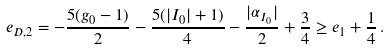<formula> <loc_0><loc_0><loc_500><loc_500>e _ { D , 2 } & = - \frac { 5 ( g _ { 0 } - 1 ) } { 2 } - \frac { 5 ( | I _ { 0 } | + 1 ) } { 4 } - \frac { | \alpha _ { I _ { 0 } } | } { 2 } + \frac { 3 } { 4 } \geq e _ { 1 } + \frac { 1 } { 4 } \, .</formula> 